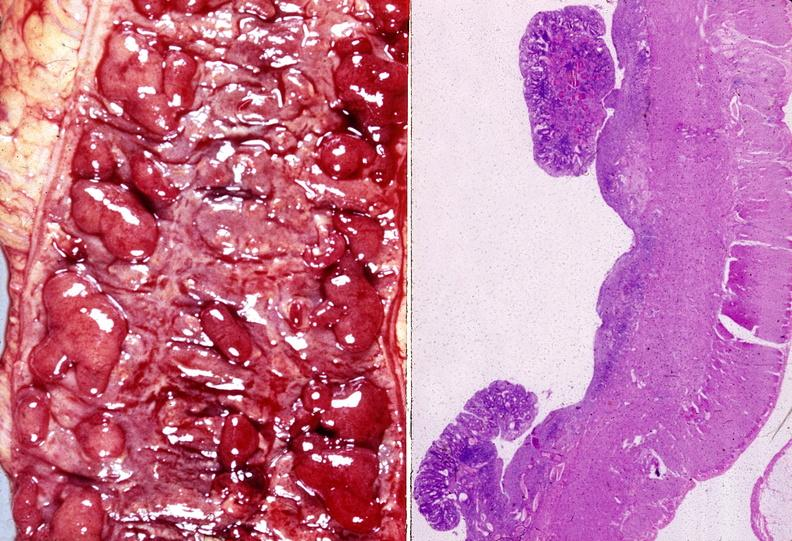what does this image show?
Answer the question using a single word or phrase. Colon 